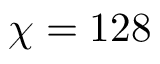Convert formula to latex. <formula><loc_0><loc_0><loc_500><loc_500>\chi = 1 2 8</formula> 